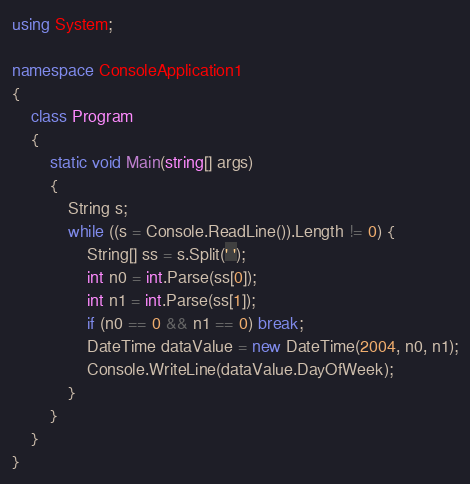Convert code to text. <code><loc_0><loc_0><loc_500><loc_500><_C#_>using System;

namespace ConsoleApplication1
{
    class Program
    {
        static void Main(string[] args)
        {
            String s;
            while ((s = Console.ReadLine()).Length != 0) {
                String[] ss = s.Split(' ');
                int n0 = int.Parse(ss[0]);
                int n1 = int.Parse(ss[1]);
                if (n0 == 0 && n1 == 0) break;
                DateTime dataValue = new DateTime(2004, n0, n1);
                Console.WriteLine(dataValue.DayOfWeek);
            }
        }
    }
}</code> 